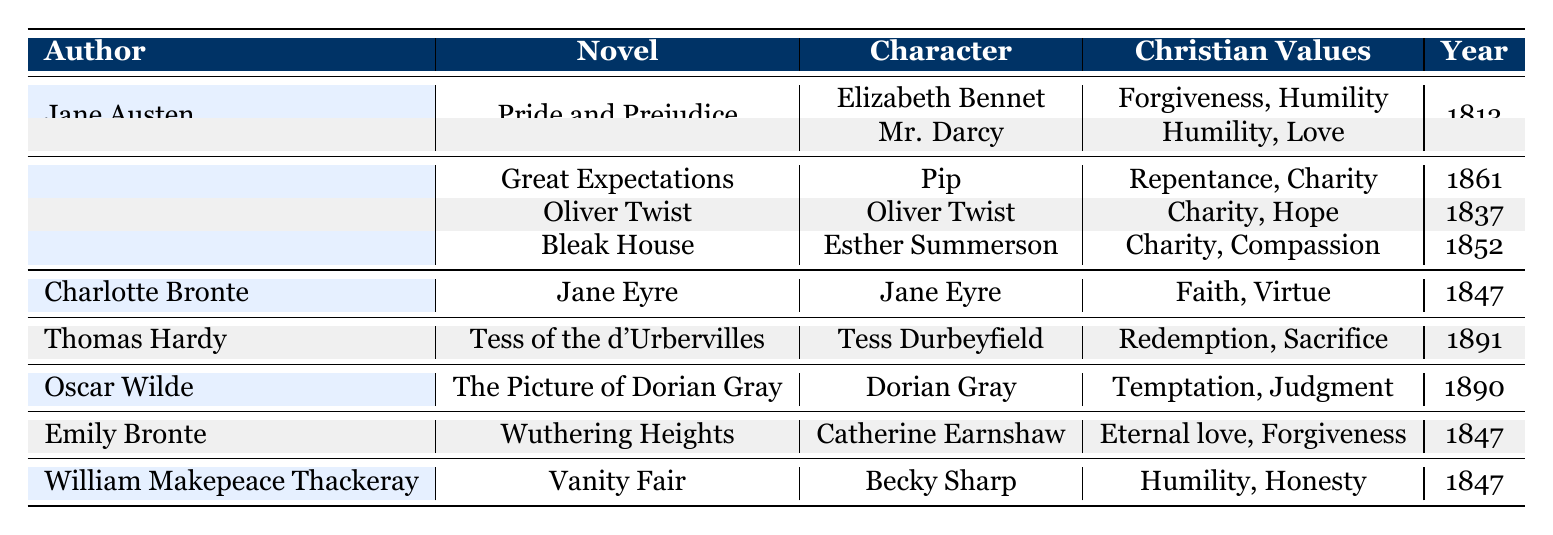What is the Christian value associated with Elizabeth Bennet? The table indicates that Elizabeth Bennet is associated with the Christian values of Forgiveness and Humility. This can be found directly in the corresponding row under the "Christian Values" column for her character.
Answer: Forgiveness, Humility Which author created the character Pip? In the table, Pip is listed under the author Charles Dickens. By locating Pip in the character column, we directly see the associated author from the same row.
Answer: Charles Dickens How many novels were published before 1850? The novels published before 1850 include "Pride and Prejudice" (1813), "Oliver Twist" (1837), "Jane Eyre" (1847), and "Vanity Fair" (1847). Counting these, we find that there are 4 novels.
Answer: 4 Is Tess Durbeyfield associated with the Christian value of Redemption? By checking the table, we see that Tess Durbeyfield has Redemption listed under her Christian values. Therefore, the statement is true.
Answer: Yes Which character has the growth arc of "Learning true gentility"? Referring to the table, the character Pip has the growth arc of "Learning true gentility." This is found within the row containing Pip's details.
Answer: Pip What is the ratio of characters that exhibit emotional moral traits (like Passion) to those that exhibit more practical traits (like Integrity)? The emotional moral traits present in the table include Passion (Jane Eyre and Catherine Earnshaw) while practical traits include Integrity (Elizabeth Bennet) and Honor (Mr. Darcy). There are 2 emotional traits (2 characters) and 2 practical traits (2 characters). Therefore, the ratio is 2:2, which simplifies to 1:1.
Answer: 1:1 Which character from the table was published most recently? Reviewing the years published, Tess Durbeyfield (1891) was published the latest compared to the others. Therefore, she is the most recent character in the table.
Answer: Tess Durbeyfield What growth arc is associated with Dorian Gray? Looking at the table, Dorian Gray's growth arc is described as "Moral decay and its consequences." This information is directly visible in his entry in the table.
Answer: Moral decay and its consequences Which author has the most characters listed in the table? By counting the entries, Charles Dickens has 3 characters listed: Pip, Oliver Twist, and Esther Summerson, which is the most for any author in the table.
Answer: Charles Dickens 